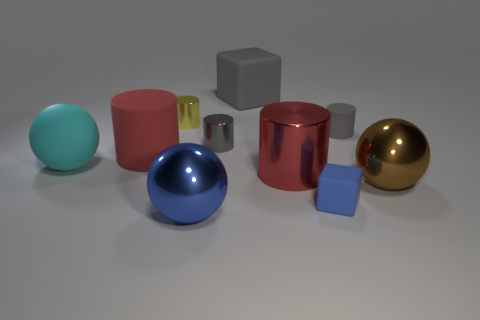Subtract all yellow cylinders. How many cylinders are left? 4 Subtract all blue cylinders. Subtract all green blocks. How many cylinders are left? 5 Subtract all balls. How many objects are left? 7 Subtract all tiny blue rubber objects. Subtract all big green rubber cylinders. How many objects are left? 9 Add 2 cylinders. How many cylinders are left? 7 Add 8 small matte cylinders. How many small matte cylinders exist? 9 Subtract 0 purple cylinders. How many objects are left? 10 